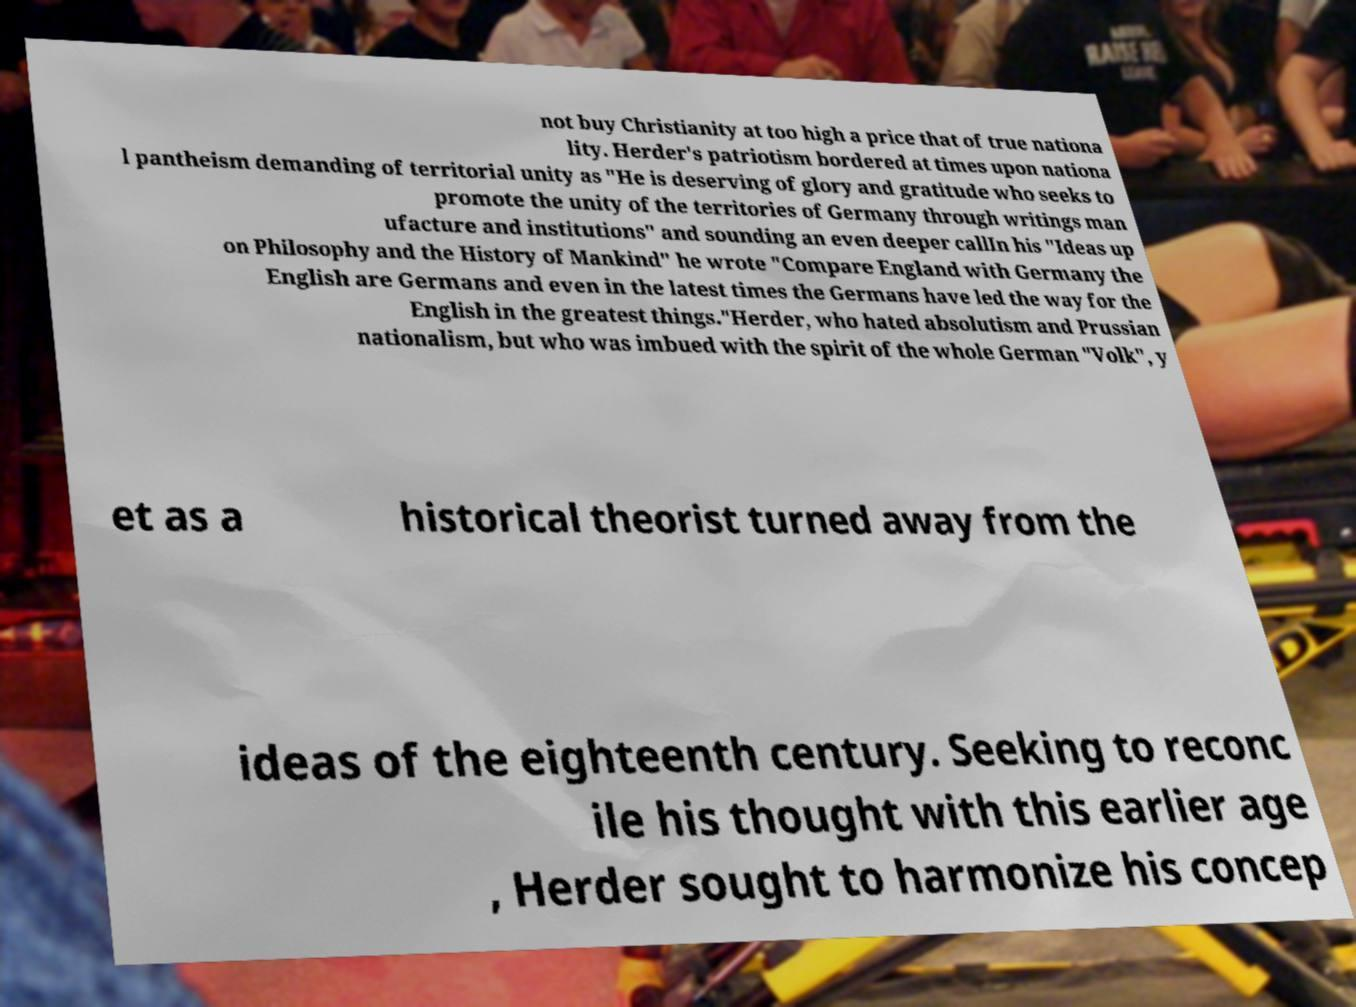Can you read and provide the text displayed in the image?This photo seems to have some interesting text. Can you extract and type it out for me? not buy Christianity at too high a price that of true nationa lity. Herder's patriotism bordered at times upon nationa l pantheism demanding of territorial unity as "He is deserving of glory and gratitude who seeks to promote the unity of the territories of Germany through writings man ufacture and institutions" and sounding an even deeper callIn his "Ideas up on Philosophy and the History of Mankind" he wrote "Compare England with Germany the English are Germans and even in the latest times the Germans have led the way for the English in the greatest things."Herder, who hated absolutism and Prussian nationalism, but who was imbued with the spirit of the whole German "Volk", y et as a historical theorist turned away from the ideas of the eighteenth century. Seeking to reconc ile his thought with this earlier age , Herder sought to harmonize his concep 